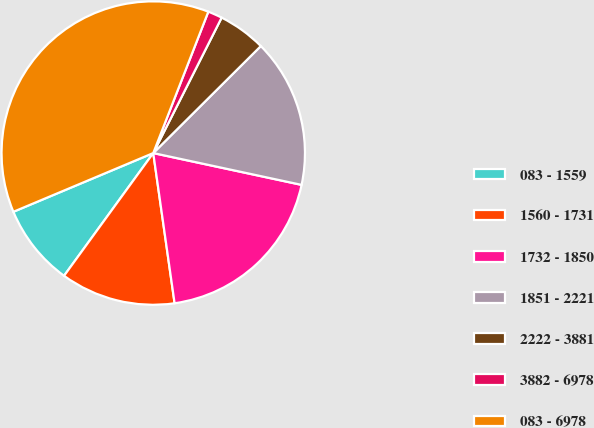Convert chart. <chart><loc_0><loc_0><loc_500><loc_500><pie_chart><fcel>083 - 1559<fcel>1560 - 1731<fcel>1732 - 1850<fcel>1851 - 2221<fcel>2222 - 3881<fcel>3882 - 6978<fcel>083 - 6978<nl><fcel>8.67%<fcel>12.25%<fcel>19.39%<fcel>15.82%<fcel>5.1%<fcel>1.53%<fcel>37.24%<nl></chart> 